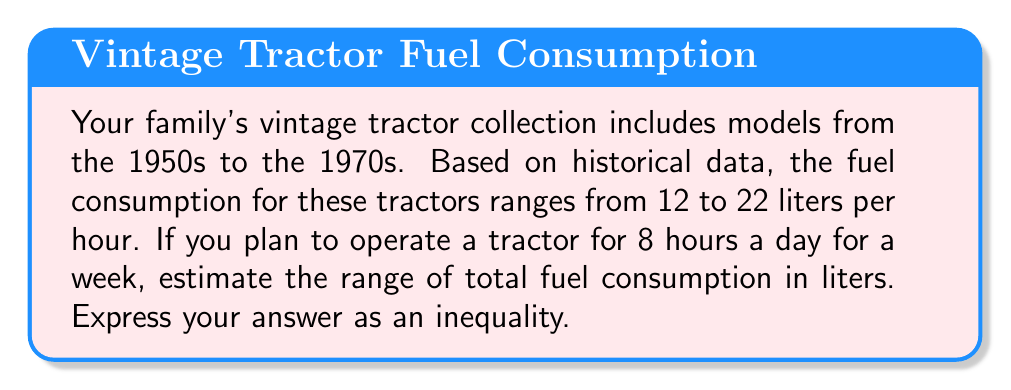Can you solve this math problem? Let's approach this step-by-step:

1) First, we need to calculate the total operating hours for a week:
   $8 \text{ hours/day} \times 7 \text{ days} = 56 \text{ hours}$

2) Now, we have two extreme cases to consider:
   - Minimum fuel consumption: 12 liters/hour
   - Maximum fuel consumption: 22 liters/hour

3) For the minimum case:
   $12 \text{ L/h} \times 56 \text{ h} = 672 \text{ L}$

4) For the maximum case:
   $22 \text{ L/h} \times 56 \text{ h} = 1232 \text{ L}$

5) Therefore, the total fuel consumption for a week will be between 672 L and 1232 L.

6) We can express this as an inequality:
   $672 \leq x \leq 1232$, where $x$ is the total fuel consumption in liters.
Answer: $672 \leq x \leq 1232$ 